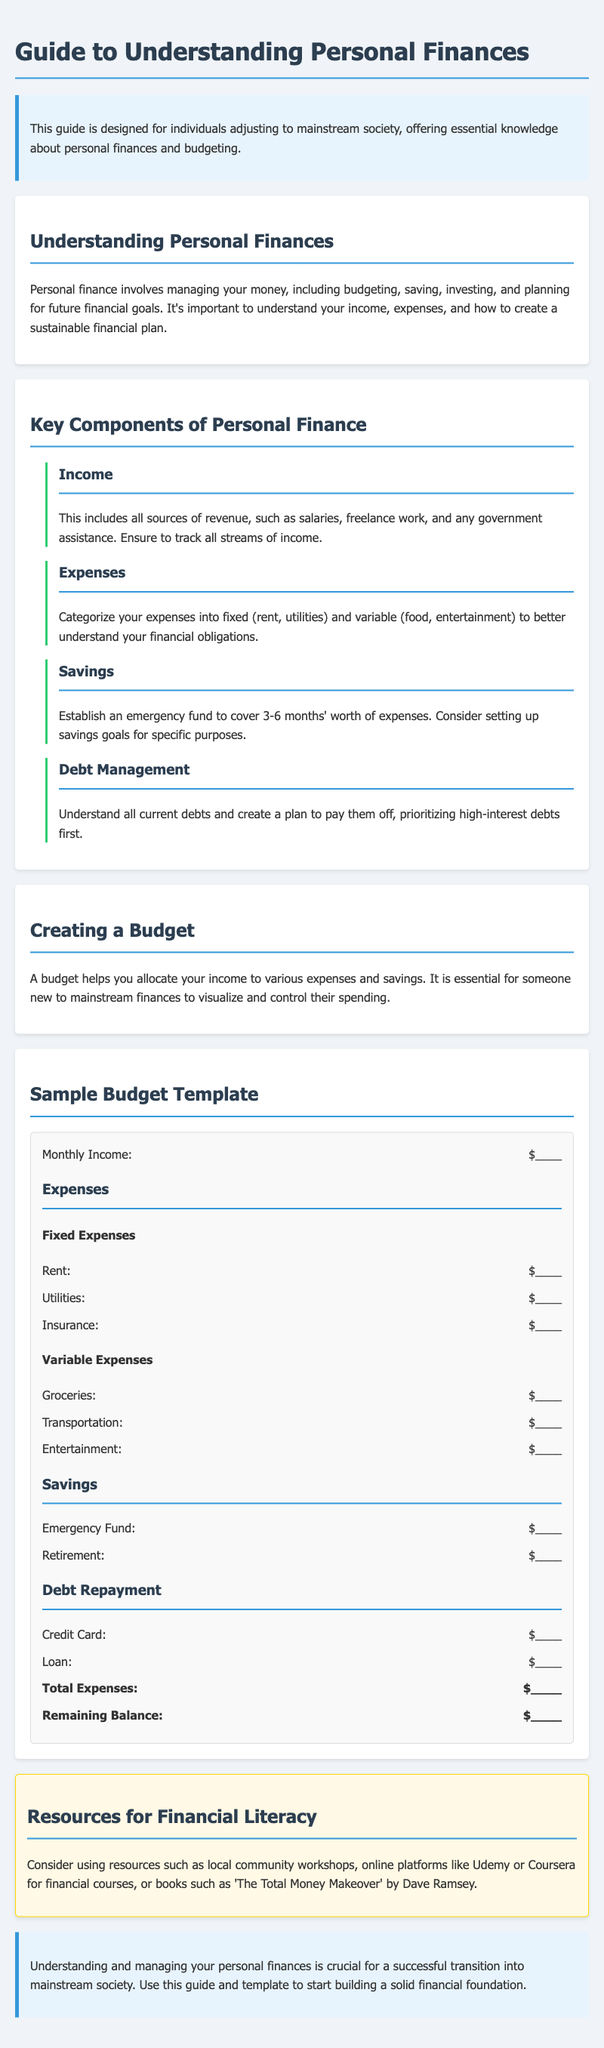What is the main topic of the guide? The main topic of the guide is about understanding personal finances.
Answer: personal finances What should be included in the emergency fund? The emergency fund should cover 3-6 months' worth of expenses.
Answer: 3-6 months What type of expenses are categorized as fixed? Fixed expenses include essentials like rent and utilities.
Answer: rent, utilities What is one resource mentioned for financial literacy? Resources for financial literacy include local community workshops.
Answer: local community workshops How many sections are there in the document? The document consists of 6 sections, including the introduction and conclusion.
Answer: 6 What should you prioritize when creating a debt management plan? You should prioritize paying off high-interest debts first.
Answer: high-interest debts What does the budget template help visualize? The budget template helps visualize how to allocate income to expenses and savings.
Answer: allocate income What is a suggested online platform for financial courses? Suggested online platforms for financial courses include Udemy and Coursera.
Answer: Udemy, Coursera What is the purpose of a budget? The purpose of a budget is to control spending and allocate income.
Answer: control spending 